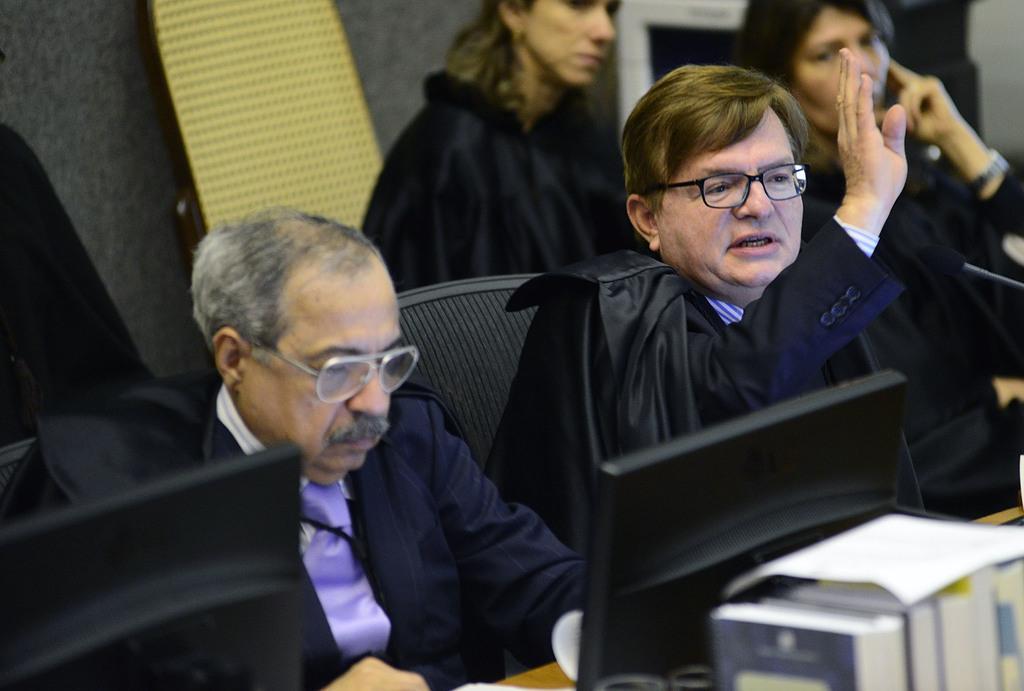Can you describe this image briefly? In this image we can see some persons sitting wearing black color coats and at the foreground of the image there are some systems. 